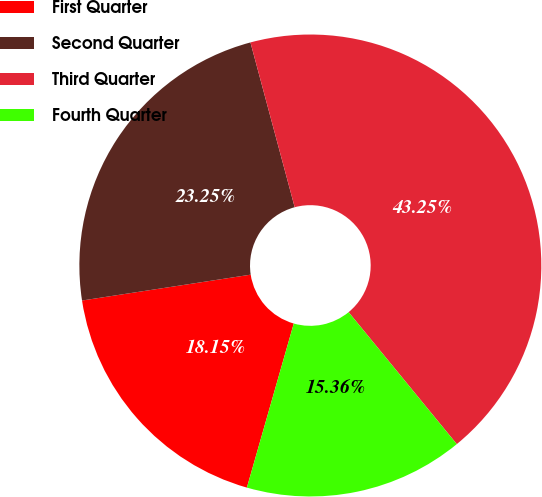<chart> <loc_0><loc_0><loc_500><loc_500><pie_chart><fcel>First Quarter<fcel>Second Quarter<fcel>Third Quarter<fcel>Fourth Quarter<nl><fcel>18.15%<fcel>23.25%<fcel>43.25%<fcel>15.36%<nl></chart> 